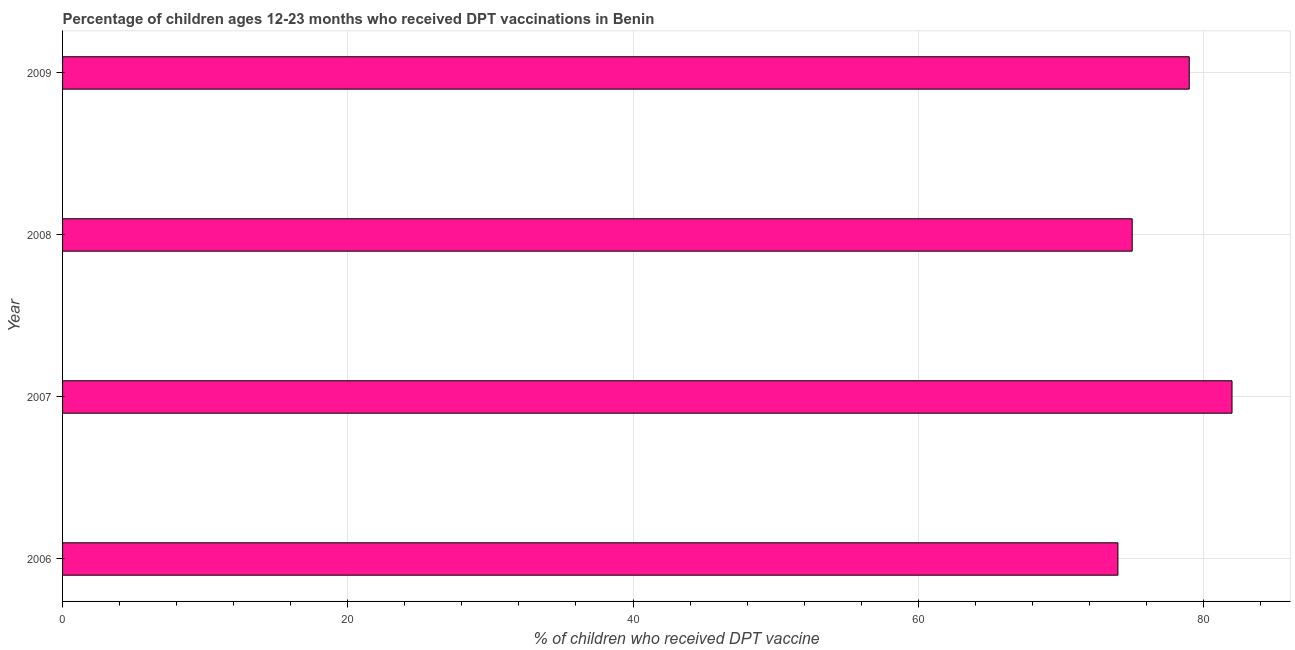Does the graph contain any zero values?
Give a very brief answer. No. Does the graph contain grids?
Provide a succinct answer. Yes. What is the title of the graph?
Your answer should be very brief. Percentage of children ages 12-23 months who received DPT vaccinations in Benin. What is the label or title of the X-axis?
Keep it short and to the point. % of children who received DPT vaccine. What is the label or title of the Y-axis?
Ensure brevity in your answer.  Year. What is the percentage of children who received dpt vaccine in 2007?
Make the answer very short. 82. Across all years, what is the minimum percentage of children who received dpt vaccine?
Make the answer very short. 74. What is the sum of the percentage of children who received dpt vaccine?
Offer a very short reply. 310. What is the difference between the percentage of children who received dpt vaccine in 2007 and 2008?
Make the answer very short. 7. What is the median percentage of children who received dpt vaccine?
Provide a short and direct response. 77. What is the ratio of the percentage of children who received dpt vaccine in 2006 to that in 2009?
Your answer should be compact. 0.94. Is the percentage of children who received dpt vaccine in 2006 less than that in 2007?
Provide a short and direct response. Yes. Is the sum of the percentage of children who received dpt vaccine in 2007 and 2008 greater than the maximum percentage of children who received dpt vaccine across all years?
Your response must be concise. Yes. What is the difference between the highest and the lowest percentage of children who received dpt vaccine?
Provide a succinct answer. 8. How many bars are there?
Provide a short and direct response. 4. How many years are there in the graph?
Ensure brevity in your answer.  4. Are the values on the major ticks of X-axis written in scientific E-notation?
Keep it short and to the point. No. What is the % of children who received DPT vaccine in 2008?
Provide a short and direct response. 75. What is the % of children who received DPT vaccine in 2009?
Make the answer very short. 79. What is the difference between the % of children who received DPT vaccine in 2006 and 2007?
Give a very brief answer. -8. What is the difference between the % of children who received DPT vaccine in 2006 and 2008?
Keep it short and to the point. -1. What is the difference between the % of children who received DPT vaccine in 2006 and 2009?
Your answer should be very brief. -5. What is the difference between the % of children who received DPT vaccine in 2008 and 2009?
Your answer should be compact. -4. What is the ratio of the % of children who received DPT vaccine in 2006 to that in 2007?
Make the answer very short. 0.9. What is the ratio of the % of children who received DPT vaccine in 2006 to that in 2009?
Keep it short and to the point. 0.94. What is the ratio of the % of children who received DPT vaccine in 2007 to that in 2008?
Your response must be concise. 1.09. What is the ratio of the % of children who received DPT vaccine in 2007 to that in 2009?
Provide a succinct answer. 1.04. What is the ratio of the % of children who received DPT vaccine in 2008 to that in 2009?
Make the answer very short. 0.95. 